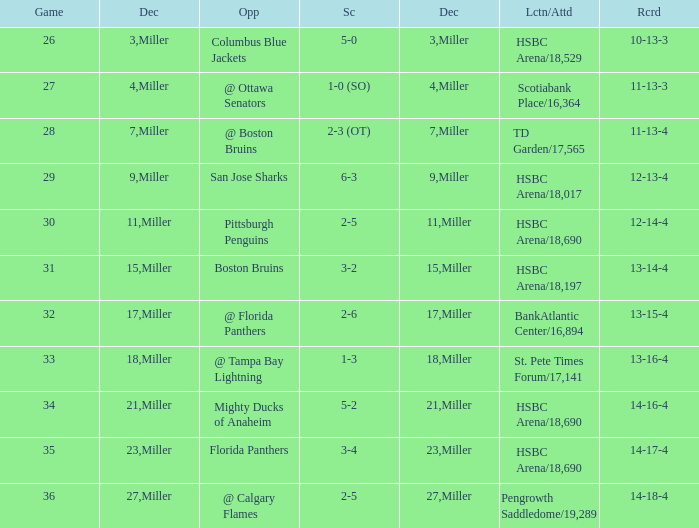Name the december for record 14-17-4 23.0. 